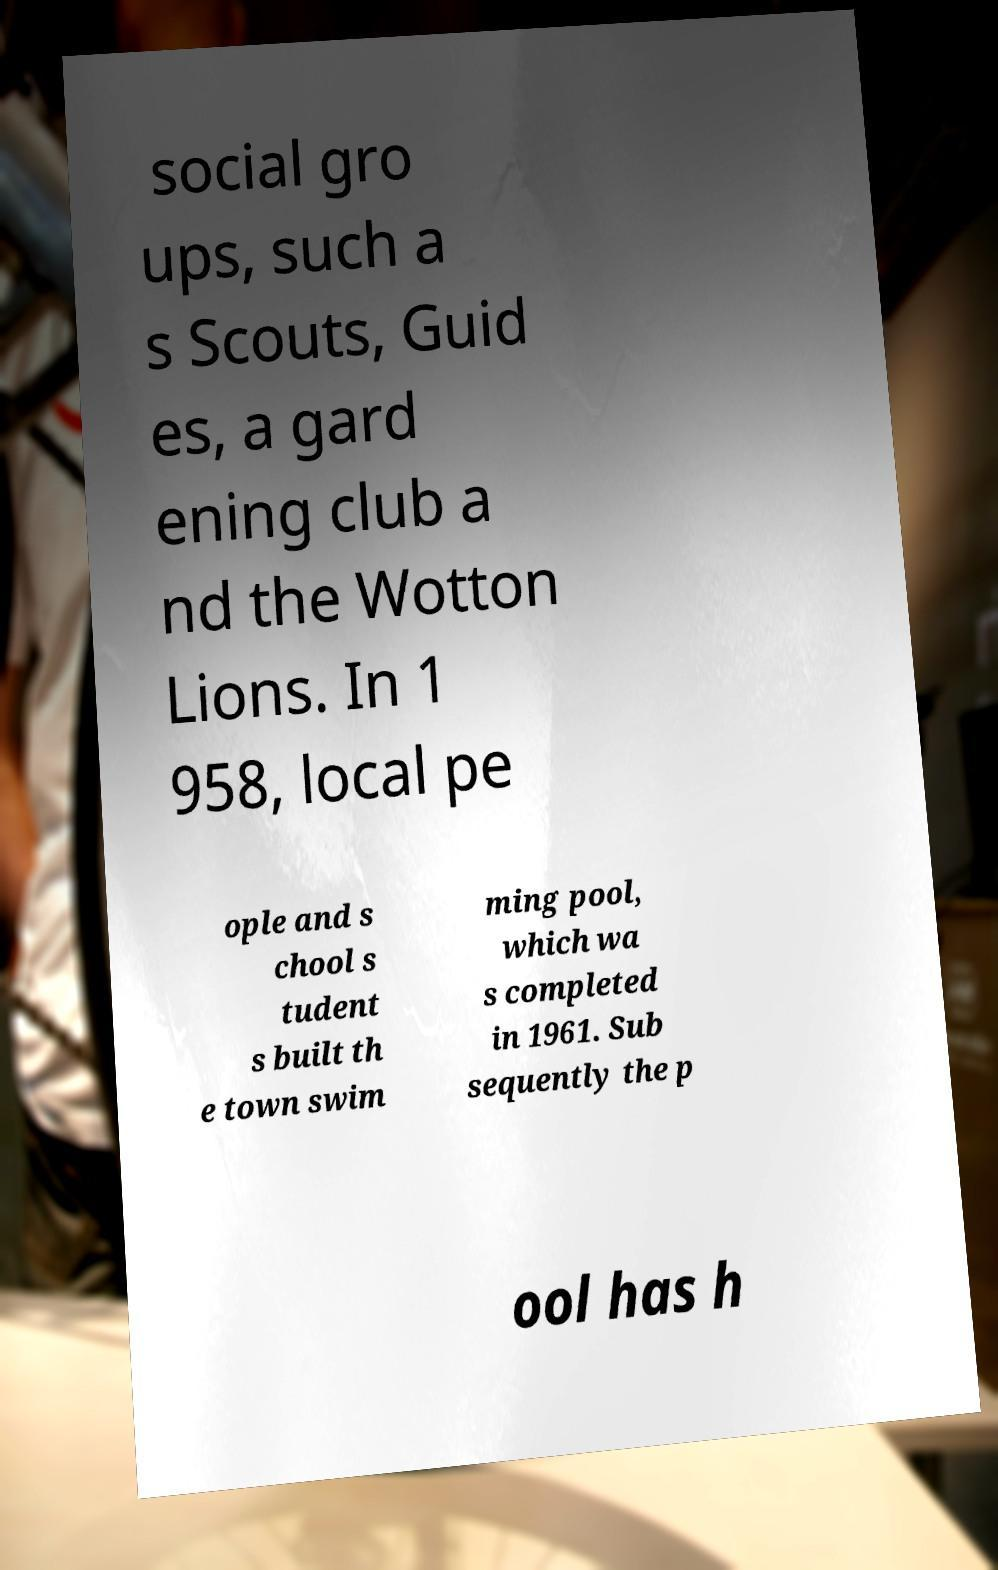Can you read and provide the text displayed in the image?This photo seems to have some interesting text. Can you extract and type it out for me? social gro ups, such a s Scouts, Guid es, a gard ening club a nd the Wotton Lions. In 1 958, local pe ople and s chool s tudent s built th e town swim ming pool, which wa s completed in 1961. Sub sequently the p ool has h 